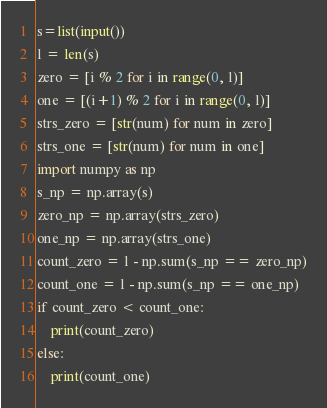Convert code to text. <code><loc_0><loc_0><loc_500><loc_500><_Python_>s=list(input())
l = len(s)
zero = [i % 2 for i in range(0, l)]
one = [(i+1) % 2 for i in range(0, l)]
strs_zero = [str(num) for num in zero]
strs_one = [str(num) for num in one]
import numpy as np
s_np = np.array(s)
zero_np = np.array(strs_zero)
one_np = np.array(strs_one)
count_zero = l - np.sum(s_np == zero_np)
count_one = l - np.sum(s_np == one_np)
if count_zero < count_one:
    print(count_zero)
else:
    print(count_one)</code> 